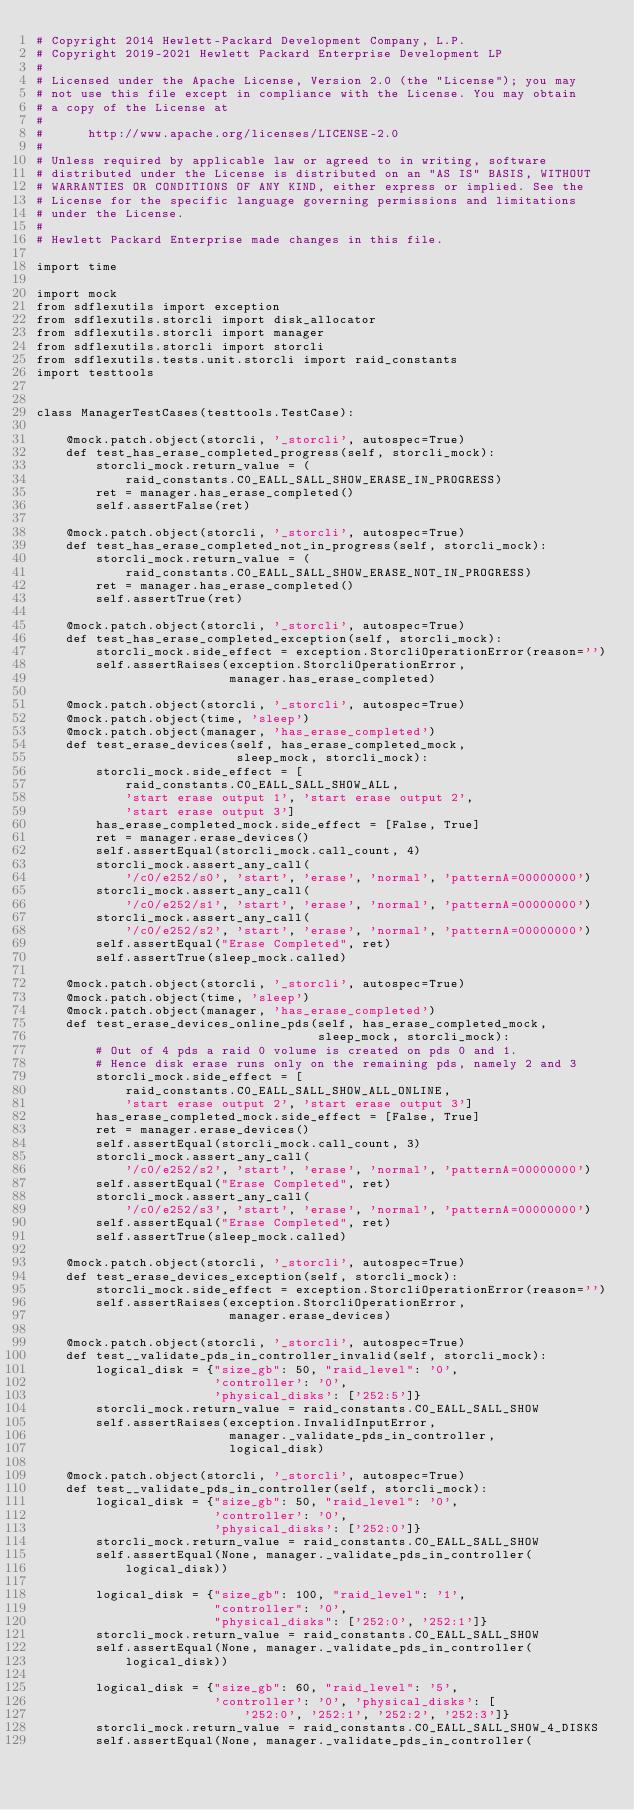Convert code to text. <code><loc_0><loc_0><loc_500><loc_500><_Python_># Copyright 2014 Hewlett-Packard Development Company, L.P.
# Copyright 2019-2021 Hewlett Packard Enterprise Development LP
#
# Licensed under the Apache License, Version 2.0 (the "License"); you may
# not use this file except in compliance with the License. You may obtain
# a copy of the License at
#
#      http://www.apache.org/licenses/LICENSE-2.0
#
# Unless required by applicable law or agreed to in writing, software
# distributed under the License is distributed on an "AS IS" BASIS, WITHOUT
# WARRANTIES OR CONDITIONS OF ANY KIND, either express or implied. See the
# License for the specific language governing permissions and limitations
# under the License.
#
# Hewlett Packard Enterprise made changes in this file.

import time

import mock
from sdflexutils import exception
from sdflexutils.storcli import disk_allocator
from sdflexutils.storcli import manager
from sdflexutils.storcli import storcli
from sdflexutils.tests.unit.storcli import raid_constants
import testtools


class ManagerTestCases(testtools.TestCase):

    @mock.patch.object(storcli, '_storcli', autospec=True)
    def test_has_erase_completed_progress(self, storcli_mock):
        storcli_mock.return_value = (
            raid_constants.C0_EALL_SALL_SHOW_ERASE_IN_PROGRESS)
        ret = manager.has_erase_completed()
        self.assertFalse(ret)

    @mock.patch.object(storcli, '_storcli', autospec=True)
    def test_has_erase_completed_not_in_progress(self, storcli_mock):
        storcli_mock.return_value = (
            raid_constants.C0_EALL_SALL_SHOW_ERASE_NOT_IN_PROGRESS)
        ret = manager.has_erase_completed()
        self.assertTrue(ret)

    @mock.patch.object(storcli, '_storcli', autospec=True)
    def test_has_erase_completed_exception(self, storcli_mock):
        storcli_mock.side_effect = exception.StorcliOperationError(reason='')
        self.assertRaises(exception.StorcliOperationError,
                          manager.has_erase_completed)

    @mock.patch.object(storcli, '_storcli', autospec=True)
    @mock.patch.object(time, 'sleep')
    @mock.patch.object(manager, 'has_erase_completed')
    def test_erase_devices(self, has_erase_completed_mock,
                           sleep_mock, storcli_mock):
        storcli_mock.side_effect = [
            raid_constants.C0_EALL_SALL_SHOW_ALL,
            'start erase output 1', 'start erase output 2',
            'start erase output 3']
        has_erase_completed_mock.side_effect = [False, True]
        ret = manager.erase_devices()
        self.assertEqual(storcli_mock.call_count, 4)
        storcli_mock.assert_any_call(
            '/c0/e252/s0', 'start', 'erase', 'normal', 'patternA=00000000')
        storcli_mock.assert_any_call(
            '/c0/e252/s1', 'start', 'erase', 'normal', 'patternA=00000000')
        storcli_mock.assert_any_call(
            '/c0/e252/s2', 'start', 'erase', 'normal', 'patternA=00000000')
        self.assertEqual("Erase Completed", ret)
        self.assertTrue(sleep_mock.called)

    @mock.patch.object(storcli, '_storcli', autospec=True)
    @mock.patch.object(time, 'sleep')
    @mock.patch.object(manager, 'has_erase_completed')
    def test_erase_devices_online_pds(self, has_erase_completed_mock,
                                      sleep_mock, storcli_mock):
        # Out of 4 pds a raid 0 volume is created on pds 0 and 1.
        # Hence disk erase runs only on the remaining pds, namely 2 and 3
        storcli_mock.side_effect = [
            raid_constants.C0_EALL_SALL_SHOW_ALL_ONLINE,
            'start erase output 2', 'start erase output 3']
        has_erase_completed_mock.side_effect = [False, True]
        ret = manager.erase_devices()
        self.assertEqual(storcli_mock.call_count, 3)
        storcli_mock.assert_any_call(
            '/c0/e252/s2', 'start', 'erase', 'normal', 'patternA=00000000')
        self.assertEqual("Erase Completed", ret)
        storcli_mock.assert_any_call(
            '/c0/e252/s3', 'start', 'erase', 'normal', 'patternA=00000000')
        self.assertEqual("Erase Completed", ret)
        self.assertTrue(sleep_mock.called)

    @mock.patch.object(storcli, '_storcli', autospec=True)
    def test_erase_devices_exception(self, storcli_mock):
        storcli_mock.side_effect = exception.StorcliOperationError(reason='')
        self.assertRaises(exception.StorcliOperationError,
                          manager.erase_devices)

    @mock.patch.object(storcli, '_storcli', autospec=True)
    def test__validate_pds_in_controller_invalid(self, storcli_mock):
        logical_disk = {"size_gb": 50, "raid_level": '0',
                        'controller': '0',
                        'physical_disks': ['252:5']}
        storcli_mock.return_value = raid_constants.C0_EALL_SALL_SHOW
        self.assertRaises(exception.InvalidInputError,
                          manager._validate_pds_in_controller,
                          logical_disk)

    @mock.patch.object(storcli, '_storcli', autospec=True)
    def test__validate_pds_in_controller(self, storcli_mock):
        logical_disk = {"size_gb": 50, "raid_level": '0',
                        'controller': '0',
                        'physical_disks': ['252:0']}
        storcli_mock.return_value = raid_constants.C0_EALL_SALL_SHOW
        self.assertEqual(None, manager._validate_pds_in_controller(
            logical_disk))

        logical_disk = {"size_gb": 100, "raid_level": '1',
                        "controller": '0',
                        "physical_disks": ['252:0', '252:1']}
        storcli_mock.return_value = raid_constants.C0_EALL_SALL_SHOW
        self.assertEqual(None, manager._validate_pds_in_controller(
            logical_disk))

        logical_disk = {"size_gb": 60, "raid_level": '5',
                        'controller': '0', 'physical_disks': [
                            '252:0', '252:1', '252:2', '252:3']}
        storcli_mock.return_value = raid_constants.C0_EALL_SALL_SHOW_4_DISKS
        self.assertEqual(None, manager._validate_pds_in_controller(</code> 